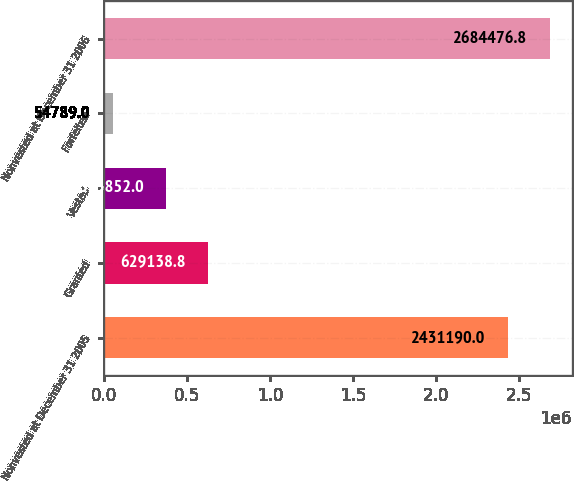Convert chart to OTSL. <chart><loc_0><loc_0><loc_500><loc_500><bar_chart><fcel>Nonvested at December 31 2005<fcel>Granted<fcel>Vested<fcel>Forfeited<fcel>Nonvested at December 31 2006<nl><fcel>2.43119e+06<fcel>629139<fcel>375852<fcel>54789<fcel>2.68448e+06<nl></chart> 